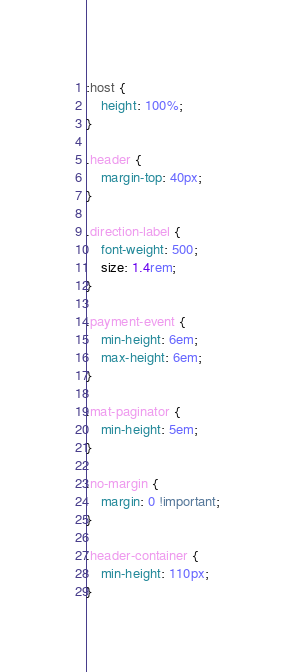<code> <loc_0><loc_0><loc_500><loc_500><_CSS_>:host {
    height: 100%;
}

.header {
    margin-top: 40px;
}

.direction-label {
    font-weight: 500;
    size: 1.4rem;
}

.payment-event {
    min-height: 6em;
    max-height: 6em;
}

.mat-paginator {
    min-height: 5em;
}

.no-margin {
    margin: 0 !important;
}

.header-container {
    min-height: 110px;
}</code> 